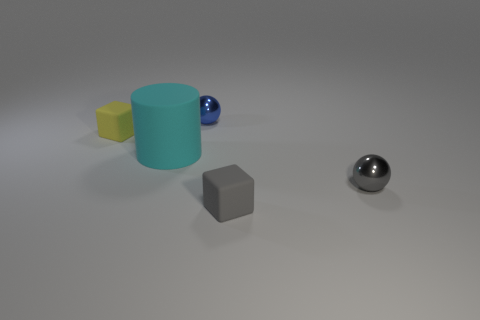Add 4 brown rubber blocks. How many objects exist? 9 Subtract all balls. How many objects are left? 3 Add 3 gray shiny objects. How many gray shiny objects exist? 4 Subtract 0 red cylinders. How many objects are left? 5 Subtract all tiny blue shiny objects. Subtract all tiny gray metallic things. How many objects are left? 3 Add 3 matte blocks. How many matte blocks are left? 5 